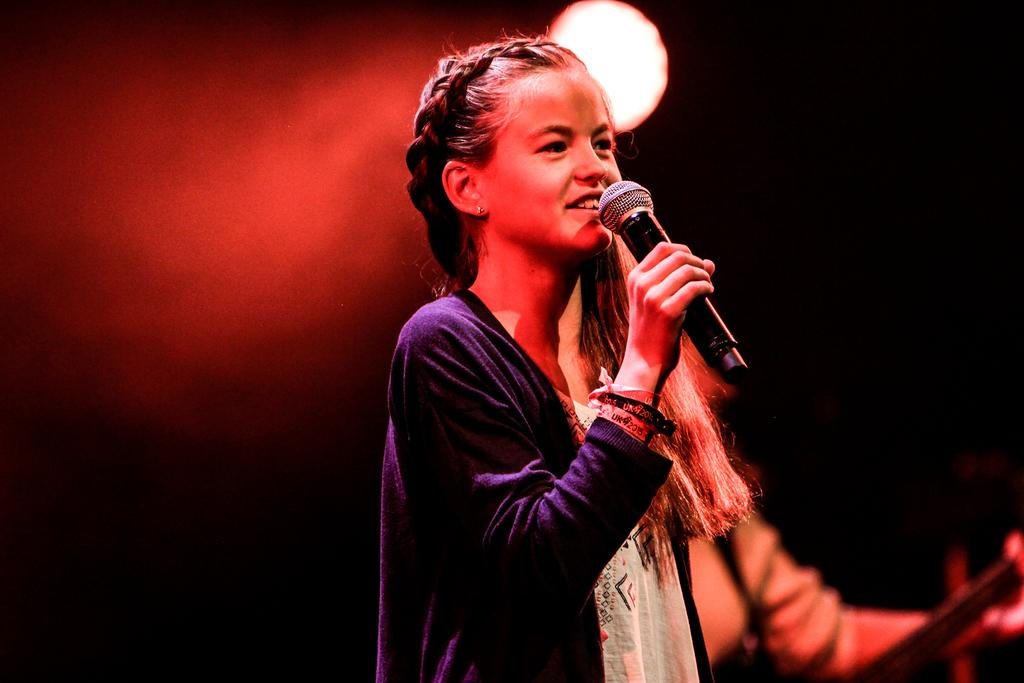Who is the main subject in the image? There is a girl in the center of the image. What is the girl doing in the image? The girl is standing and smiling. What is the girl holding in the image? The girl is holding a microphone. What can be seen in the background of the image? There is light and a few other objects in the background of the image. What type of grape is the girl eating in the image? There is no grape present in the image, and the girl is not eating anything. What order does the girl have to follow while holding the microphone? There is no specific order mentioned in the image, and the girl is simply holding the microphone. 